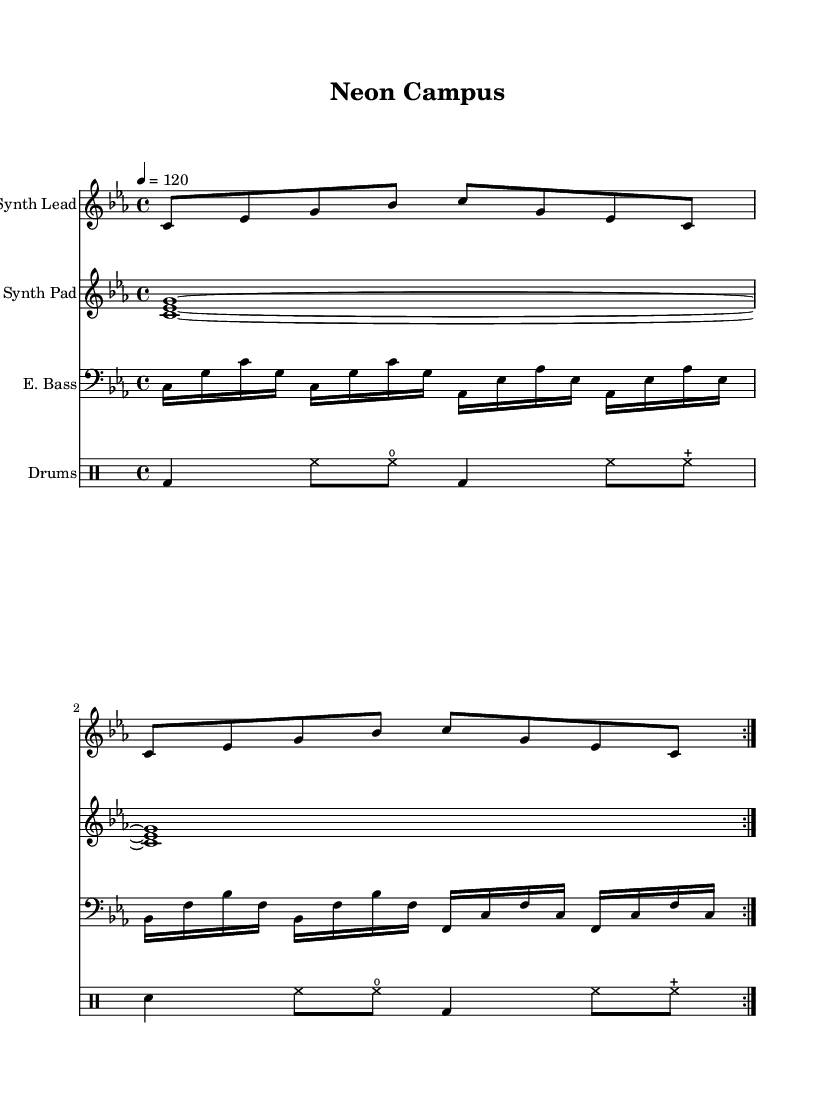What is the key signature of this music? The key signature is indicated at the beginning of the staff and shows three flats, which corresponds to C minor.
Answer: C minor What is the time signature? The time signature is found at the beginning of the score, represented by the fraction directly after the clef, indicating 4 beats per measure.
Answer: 4/4 What is the tempo marking? The tempo marking is shown at the beginning of the sheet music, stating "4 = 120," which indicates the number of quarter notes per minute.
Answer: 120 How many times is the synth lead repeated? The repeat markings in the synth lead section indicate that the melody is played twice.
Answer: 2 What is the instrument name for the bass? The instrument designation for the bass section is labeled "E. Bass," showing it is an electric bass instrument.
Answer: E. Bass What type of drum pattern is used? The drum part is written in a standard "DrumStaff" format, indicating a march-like pattern consisting of kick (bd), snare (sn), and hi-hat (hh) sounds.
Answer: Standard What chords are used in the synth pad? The synth pad features the chord C minor, represented by the combination of notes C, E flat, and G in a sustained manner.
Answer: C minor 